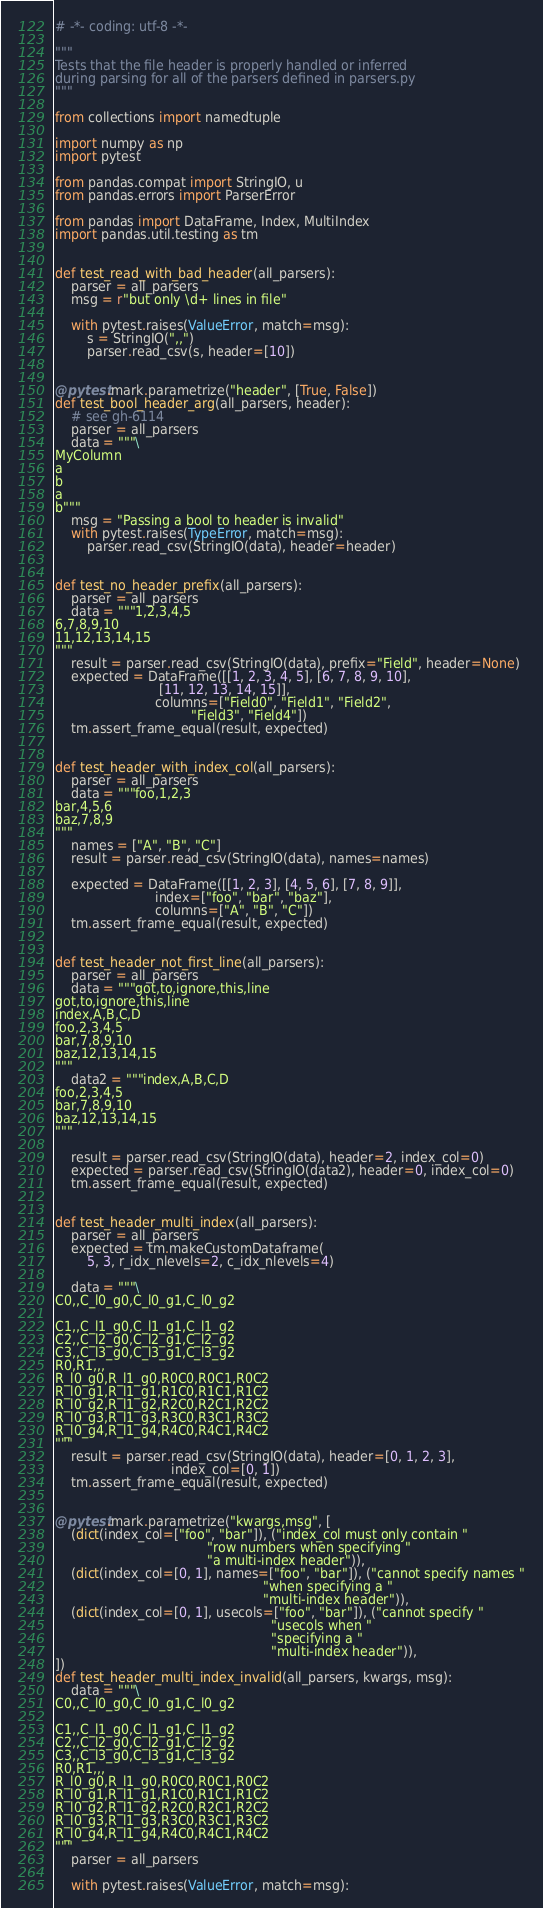Convert code to text. <code><loc_0><loc_0><loc_500><loc_500><_Python_># -*- coding: utf-8 -*-

"""
Tests that the file header is properly handled or inferred
during parsing for all of the parsers defined in parsers.py
"""

from collections import namedtuple

import numpy as np
import pytest

from pandas.compat import StringIO, u
from pandas.errors import ParserError

from pandas import DataFrame, Index, MultiIndex
import pandas.util.testing as tm


def test_read_with_bad_header(all_parsers):
    parser = all_parsers
    msg = r"but only \d+ lines in file"

    with pytest.raises(ValueError, match=msg):
        s = StringIO(",,")
        parser.read_csv(s, header=[10])


@pytest.mark.parametrize("header", [True, False])
def test_bool_header_arg(all_parsers, header):
    # see gh-6114
    parser = all_parsers
    data = """\
MyColumn
a
b
a
b"""
    msg = "Passing a bool to header is invalid"
    with pytest.raises(TypeError, match=msg):
        parser.read_csv(StringIO(data), header=header)


def test_no_header_prefix(all_parsers):
    parser = all_parsers
    data = """1,2,3,4,5
6,7,8,9,10
11,12,13,14,15
"""
    result = parser.read_csv(StringIO(data), prefix="Field", header=None)
    expected = DataFrame([[1, 2, 3, 4, 5], [6, 7, 8, 9, 10],
                          [11, 12, 13, 14, 15]],
                         columns=["Field0", "Field1", "Field2",
                                  "Field3", "Field4"])
    tm.assert_frame_equal(result, expected)


def test_header_with_index_col(all_parsers):
    parser = all_parsers
    data = """foo,1,2,3
bar,4,5,6
baz,7,8,9
"""
    names = ["A", "B", "C"]
    result = parser.read_csv(StringIO(data), names=names)

    expected = DataFrame([[1, 2, 3], [4, 5, 6], [7, 8, 9]],
                         index=["foo", "bar", "baz"],
                         columns=["A", "B", "C"])
    tm.assert_frame_equal(result, expected)


def test_header_not_first_line(all_parsers):
    parser = all_parsers
    data = """got,to,ignore,this,line
got,to,ignore,this,line
index,A,B,C,D
foo,2,3,4,5
bar,7,8,9,10
baz,12,13,14,15
"""
    data2 = """index,A,B,C,D
foo,2,3,4,5
bar,7,8,9,10
baz,12,13,14,15
"""

    result = parser.read_csv(StringIO(data), header=2, index_col=0)
    expected = parser.read_csv(StringIO(data2), header=0, index_col=0)
    tm.assert_frame_equal(result, expected)


def test_header_multi_index(all_parsers):
    parser = all_parsers
    expected = tm.makeCustomDataframe(
        5, 3, r_idx_nlevels=2, c_idx_nlevels=4)

    data = """\
C0,,C_l0_g0,C_l0_g1,C_l0_g2

C1,,C_l1_g0,C_l1_g1,C_l1_g2
C2,,C_l2_g0,C_l2_g1,C_l2_g2
C3,,C_l3_g0,C_l3_g1,C_l3_g2
R0,R1,,,
R_l0_g0,R_l1_g0,R0C0,R0C1,R0C2
R_l0_g1,R_l1_g1,R1C0,R1C1,R1C2
R_l0_g2,R_l1_g2,R2C0,R2C1,R2C2
R_l0_g3,R_l1_g3,R3C0,R3C1,R3C2
R_l0_g4,R_l1_g4,R4C0,R4C1,R4C2
"""
    result = parser.read_csv(StringIO(data), header=[0, 1, 2, 3],
                             index_col=[0, 1])
    tm.assert_frame_equal(result, expected)


@pytest.mark.parametrize("kwargs,msg", [
    (dict(index_col=["foo", "bar"]), ("index_col must only contain "
                                      "row numbers when specifying "
                                      "a multi-index header")),
    (dict(index_col=[0, 1], names=["foo", "bar"]), ("cannot specify names "
                                                    "when specifying a "
                                                    "multi-index header")),
    (dict(index_col=[0, 1], usecols=["foo", "bar"]), ("cannot specify "
                                                      "usecols when "
                                                      "specifying a "
                                                      "multi-index header")),
])
def test_header_multi_index_invalid(all_parsers, kwargs, msg):
    data = """\
C0,,C_l0_g0,C_l0_g1,C_l0_g2

C1,,C_l1_g0,C_l1_g1,C_l1_g2
C2,,C_l2_g0,C_l2_g1,C_l2_g2
C3,,C_l3_g0,C_l3_g1,C_l3_g2
R0,R1,,,
R_l0_g0,R_l1_g0,R0C0,R0C1,R0C2
R_l0_g1,R_l1_g1,R1C0,R1C1,R1C2
R_l0_g2,R_l1_g2,R2C0,R2C1,R2C2
R_l0_g3,R_l1_g3,R3C0,R3C1,R3C2
R_l0_g4,R_l1_g4,R4C0,R4C1,R4C2
"""
    parser = all_parsers

    with pytest.raises(ValueError, match=msg):</code> 